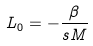<formula> <loc_0><loc_0><loc_500><loc_500>L _ { 0 } = - \frac { \beta } { s M }</formula> 